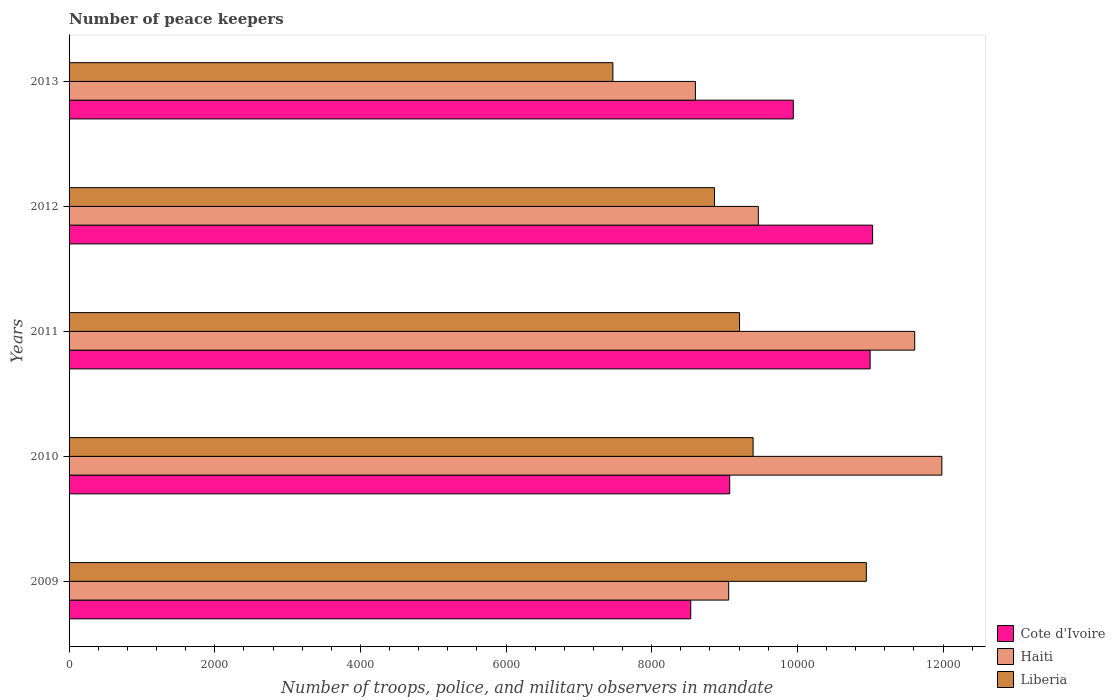How many groups of bars are there?
Your answer should be compact. 5. Are the number of bars per tick equal to the number of legend labels?
Your response must be concise. Yes. How many bars are there on the 3rd tick from the bottom?
Offer a very short reply. 3. What is the label of the 4th group of bars from the top?
Your response must be concise. 2010. In how many cases, is the number of bars for a given year not equal to the number of legend labels?
Your response must be concise. 0. What is the number of peace keepers in in Haiti in 2009?
Ensure brevity in your answer.  9057. Across all years, what is the maximum number of peace keepers in in Liberia?
Your answer should be compact. 1.09e+04. Across all years, what is the minimum number of peace keepers in in Cote d'Ivoire?
Your answer should be compact. 8536. In which year was the number of peace keepers in in Liberia minimum?
Your answer should be compact. 2013. What is the total number of peace keepers in in Liberia in the graph?
Provide a short and direct response. 4.59e+04. What is the difference between the number of peace keepers in in Cote d'Ivoire in 2012 and that in 2013?
Give a very brief answer. 1089. What is the difference between the number of peace keepers in in Haiti in 2010 and the number of peace keepers in in Liberia in 2012?
Make the answer very short. 3122. What is the average number of peace keepers in in Haiti per year?
Your answer should be compact. 1.01e+04. In the year 2009, what is the difference between the number of peace keepers in in Haiti and number of peace keepers in in Liberia?
Offer a very short reply. -1890. In how many years, is the number of peace keepers in in Cote d'Ivoire greater than 2000 ?
Your response must be concise. 5. What is the ratio of the number of peace keepers in in Cote d'Ivoire in 2009 to that in 2010?
Provide a short and direct response. 0.94. What is the difference between the highest and the second highest number of peace keepers in in Liberia?
Your answer should be very brief. 1555. What is the difference between the highest and the lowest number of peace keepers in in Haiti?
Keep it short and to the point. 3384. In how many years, is the number of peace keepers in in Cote d'Ivoire greater than the average number of peace keepers in in Cote d'Ivoire taken over all years?
Provide a short and direct response. 3. What does the 3rd bar from the top in 2012 represents?
Your answer should be compact. Cote d'Ivoire. What does the 1st bar from the bottom in 2009 represents?
Provide a succinct answer. Cote d'Ivoire. Is it the case that in every year, the sum of the number of peace keepers in in Liberia and number of peace keepers in in Cote d'Ivoire is greater than the number of peace keepers in in Haiti?
Your answer should be very brief. Yes. How many bars are there?
Keep it short and to the point. 15. Are all the bars in the graph horizontal?
Your answer should be compact. Yes. What is the difference between two consecutive major ticks on the X-axis?
Make the answer very short. 2000. How many legend labels are there?
Give a very brief answer. 3. How are the legend labels stacked?
Your response must be concise. Vertical. What is the title of the graph?
Keep it short and to the point. Number of peace keepers. What is the label or title of the X-axis?
Offer a terse response. Number of troops, police, and military observers in mandate. What is the Number of troops, police, and military observers in mandate in Cote d'Ivoire in 2009?
Offer a terse response. 8536. What is the Number of troops, police, and military observers in mandate of Haiti in 2009?
Provide a succinct answer. 9057. What is the Number of troops, police, and military observers in mandate of Liberia in 2009?
Ensure brevity in your answer.  1.09e+04. What is the Number of troops, police, and military observers in mandate in Cote d'Ivoire in 2010?
Offer a terse response. 9071. What is the Number of troops, police, and military observers in mandate in Haiti in 2010?
Ensure brevity in your answer.  1.20e+04. What is the Number of troops, police, and military observers in mandate in Liberia in 2010?
Keep it short and to the point. 9392. What is the Number of troops, police, and military observers in mandate of Cote d'Ivoire in 2011?
Make the answer very short. 1.10e+04. What is the Number of troops, police, and military observers in mandate in Haiti in 2011?
Make the answer very short. 1.16e+04. What is the Number of troops, police, and military observers in mandate of Liberia in 2011?
Provide a succinct answer. 9206. What is the Number of troops, police, and military observers in mandate in Cote d'Ivoire in 2012?
Provide a succinct answer. 1.10e+04. What is the Number of troops, police, and military observers in mandate in Haiti in 2012?
Keep it short and to the point. 9464. What is the Number of troops, police, and military observers in mandate of Liberia in 2012?
Offer a very short reply. 8862. What is the Number of troops, police, and military observers in mandate in Cote d'Ivoire in 2013?
Give a very brief answer. 9944. What is the Number of troops, police, and military observers in mandate of Haiti in 2013?
Provide a succinct answer. 8600. What is the Number of troops, police, and military observers in mandate in Liberia in 2013?
Offer a very short reply. 7467. Across all years, what is the maximum Number of troops, police, and military observers in mandate of Cote d'Ivoire?
Provide a short and direct response. 1.10e+04. Across all years, what is the maximum Number of troops, police, and military observers in mandate in Haiti?
Provide a succinct answer. 1.20e+04. Across all years, what is the maximum Number of troops, police, and military observers in mandate in Liberia?
Your answer should be very brief. 1.09e+04. Across all years, what is the minimum Number of troops, police, and military observers in mandate in Cote d'Ivoire?
Your answer should be very brief. 8536. Across all years, what is the minimum Number of troops, police, and military observers in mandate in Haiti?
Your answer should be compact. 8600. Across all years, what is the minimum Number of troops, police, and military observers in mandate in Liberia?
Offer a terse response. 7467. What is the total Number of troops, police, and military observers in mandate of Cote d'Ivoire in the graph?
Make the answer very short. 4.96e+04. What is the total Number of troops, police, and military observers in mandate of Haiti in the graph?
Your answer should be compact. 5.07e+04. What is the total Number of troops, police, and military observers in mandate of Liberia in the graph?
Offer a terse response. 4.59e+04. What is the difference between the Number of troops, police, and military observers in mandate in Cote d'Ivoire in 2009 and that in 2010?
Your answer should be very brief. -535. What is the difference between the Number of troops, police, and military observers in mandate of Haiti in 2009 and that in 2010?
Your response must be concise. -2927. What is the difference between the Number of troops, police, and military observers in mandate in Liberia in 2009 and that in 2010?
Offer a terse response. 1555. What is the difference between the Number of troops, police, and military observers in mandate of Cote d'Ivoire in 2009 and that in 2011?
Keep it short and to the point. -2463. What is the difference between the Number of troops, police, and military observers in mandate in Haiti in 2009 and that in 2011?
Keep it short and to the point. -2554. What is the difference between the Number of troops, police, and military observers in mandate of Liberia in 2009 and that in 2011?
Give a very brief answer. 1741. What is the difference between the Number of troops, police, and military observers in mandate in Cote d'Ivoire in 2009 and that in 2012?
Give a very brief answer. -2497. What is the difference between the Number of troops, police, and military observers in mandate in Haiti in 2009 and that in 2012?
Offer a very short reply. -407. What is the difference between the Number of troops, police, and military observers in mandate in Liberia in 2009 and that in 2012?
Your answer should be compact. 2085. What is the difference between the Number of troops, police, and military observers in mandate of Cote d'Ivoire in 2009 and that in 2013?
Offer a terse response. -1408. What is the difference between the Number of troops, police, and military observers in mandate of Haiti in 2009 and that in 2013?
Your answer should be compact. 457. What is the difference between the Number of troops, police, and military observers in mandate of Liberia in 2009 and that in 2013?
Keep it short and to the point. 3480. What is the difference between the Number of troops, police, and military observers in mandate of Cote d'Ivoire in 2010 and that in 2011?
Keep it short and to the point. -1928. What is the difference between the Number of troops, police, and military observers in mandate of Haiti in 2010 and that in 2011?
Make the answer very short. 373. What is the difference between the Number of troops, police, and military observers in mandate of Liberia in 2010 and that in 2011?
Make the answer very short. 186. What is the difference between the Number of troops, police, and military observers in mandate of Cote d'Ivoire in 2010 and that in 2012?
Keep it short and to the point. -1962. What is the difference between the Number of troops, police, and military observers in mandate in Haiti in 2010 and that in 2012?
Offer a terse response. 2520. What is the difference between the Number of troops, police, and military observers in mandate of Liberia in 2010 and that in 2012?
Your answer should be very brief. 530. What is the difference between the Number of troops, police, and military observers in mandate of Cote d'Ivoire in 2010 and that in 2013?
Your response must be concise. -873. What is the difference between the Number of troops, police, and military observers in mandate in Haiti in 2010 and that in 2013?
Keep it short and to the point. 3384. What is the difference between the Number of troops, police, and military observers in mandate in Liberia in 2010 and that in 2013?
Offer a very short reply. 1925. What is the difference between the Number of troops, police, and military observers in mandate in Cote d'Ivoire in 2011 and that in 2012?
Make the answer very short. -34. What is the difference between the Number of troops, police, and military observers in mandate of Haiti in 2011 and that in 2012?
Your answer should be compact. 2147. What is the difference between the Number of troops, police, and military observers in mandate of Liberia in 2011 and that in 2012?
Provide a succinct answer. 344. What is the difference between the Number of troops, police, and military observers in mandate of Cote d'Ivoire in 2011 and that in 2013?
Your response must be concise. 1055. What is the difference between the Number of troops, police, and military observers in mandate in Haiti in 2011 and that in 2013?
Offer a very short reply. 3011. What is the difference between the Number of troops, police, and military observers in mandate in Liberia in 2011 and that in 2013?
Your answer should be compact. 1739. What is the difference between the Number of troops, police, and military observers in mandate in Cote d'Ivoire in 2012 and that in 2013?
Offer a terse response. 1089. What is the difference between the Number of troops, police, and military observers in mandate in Haiti in 2012 and that in 2013?
Give a very brief answer. 864. What is the difference between the Number of troops, police, and military observers in mandate of Liberia in 2012 and that in 2013?
Your response must be concise. 1395. What is the difference between the Number of troops, police, and military observers in mandate in Cote d'Ivoire in 2009 and the Number of troops, police, and military observers in mandate in Haiti in 2010?
Make the answer very short. -3448. What is the difference between the Number of troops, police, and military observers in mandate in Cote d'Ivoire in 2009 and the Number of troops, police, and military observers in mandate in Liberia in 2010?
Your answer should be compact. -856. What is the difference between the Number of troops, police, and military observers in mandate of Haiti in 2009 and the Number of troops, police, and military observers in mandate of Liberia in 2010?
Offer a terse response. -335. What is the difference between the Number of troops, police, and military observers in mandate of Cote d'Ivoire in 2009 and the Number of troops, police, and military observers in mandate of Haiti in 2011?
Offer a very short reply. -3075. What is the difference between the Number of troops, police, and military observers in mandate of Cote d'Ivoire in 2009 and the Number of troops, police, and military observers in mandate of Liberia in 2011?
Ensure brevity in your answer.  -670. What is the difference between the Number of troops, police, and military observers in mandate of Haiti in 2009 and the Number of troops, police, and military observers in mandate of Liberia in 2011?
Provide a short and direct response. -149. What is the difference between the Number of troops, police, and military observers in mandate of Cote d'Ivoire in 2009 and the Number of troops, police, and military observers in mandate of Haiti in 2012?
Give a very brief answer. -928. What is the difference between the Number of troops, police, and military observers in mandate of Cote d'Ivoire in 2009 and the Number of troops, police, and military observers in mandate of Liberia in 2012?
Your answer should be compact. -326. What is the difference between the Number of troops, police, and military observers in mandate in Haiti in 2009 and the Number of troops, police, and military observers in mandate in Liberia in 2012?
Your answer should be compact. 195. What is the difference between the Number of troops, police, and military observers in mandate of Cote d'Ivoire in 2009 and the Number of troops, police, and military observers in mandate of Haiti in 2013?
Offer a terse response. -64. What is the difference between the Number of troops, police, and military observers in mandate of Cote d'Ivoire in 2009 and the Number of troops, police, and military observers in mandate of Liberia in 2013?
Offer a terse response. 1069. What is the difference between the Number of troops, police, and military observers in mandate in Haiti in 2009 and the Number of troops, police, and military observers in mandate in Liberia in 2013?
Your response must be concise. 1590. What is the difference between the Number of troops, police, and military observers in mandate of Cote d'Ivoire in 2010 and the Number of troops, police, and military observers in mandate of Haiti in 2011?
Offer a very short reply. -2540. What is the difference between the Number of troops, police, and military observers in mandate of Cote d'Ivoire in 2010 and the Number of troops, police, and military observers in mandate of Liberia in 2011?
Provide a short and direct response. -135. What is the difference between the Number of troops, police, and military observers in mandate in Haiti in 2010 and the Number of troops, police, and military observers in mandate in Liberia in 2011?
Offer a very short reply. 2778. What is the difference between the Number of troops, police, and military observers in mandate in Cote d'Ivoire in 2010 and the Number of troops, police, and military observers in mandate in Haiti in 2012?
Provide a short and direct response. -393. What is the difference between the Number of troops, police, and military observers in mandate in Cote d'Ivoire in 2010 and the Number of troops, police, and military observers in mandate in Liberia in 2012?
Ensure brevity in your answer.  209. What is the difference between the Number of troops, police, and military observers in mandate of Haiti in 2010 and the Number of troops, police, and military observers in mandate of Liberia in 2012?
Your answer should be very brief. 3122. What is the difference between the Number of troops, police, and military observers in mandate of Cote d'Ivoire in 2010 and the Number of troops, police, and military observers in mandate of Haiti in 2013?
Ensure brevity in your answer.  471. What is the difference between the Number of troops, police, and military observers in mandate in Cote d'Ivoire in 2010 and the Number of troops, police, and military observers in mandate in Liberia in 2013?
Keep it short and to the point. 1604. What is the difference between the Number of troops, police, and military observers in mandate of Haiti in 2010 and the Number of troops, police, and military observers in mandate of Liberia in 2013?
Your response must be concise. 4517. What is the difference between the Number of troops, police, and military observers in mandate in Cote d'Ivoire in 2011 and the Number of troops, police, and military observers in mandate in Haiti in 2012?
Offer a terse response. 1535. What is the difference between the Number of troops, police, and military observers in mandate in Cote d'Ivoire in 2011 and the Number of troops, police, and military observers in mandate in Liberia in 2012?
Offer a terse response. 2137. What is the difference between the Number of troops, police, and military observers in mandate in Haiti in 2011 and the Number of troops, police, and military observers in mandate in Liberia in 2012?
Give a very brief answer. 2749. What is the difference between the Number of troops, police, and military observers in mandate of Cote d'Ivoire in 2011 and the Number of troops, police, and military observers in mandate of Haiti in 2013?
Provide a succinct answer. 2399. What is the difference between the Number of troops, police, and military observers in mandate of Cote d'Ivoire in 2011 and the Number of troops, police, and military observers in mandate of Liberia in 2013?
Offer a very short reply. 3532. What is the difference between the Number of troops, police, and military observers in mandate of Haiti in 2011 and the Number of troops, police, and military observers in mandate of Liberia in 2013?
Your answer should be very brief. 4144. What is the difference between the Number of troops, police, and military observers in mandate of Cote d'Ivoire in 2012 and the Number of troops, police, and military observers in mandate of Haiti in 2013?
Offer a terse response. 2433. What is the difference between the Number of troops, police, and military observers in mandate of Cote d'Ivoire in 2012 and the Number of troops, police, and military observers in mandate of Liberia in 2013?
Offer a terse response. 3566. What is the difference between the Number of troops, police, and military observers in mandate in Haiti in 2012 and the Number of troops, police, and military observers in mandate in Liberia in 2013?
Offer a terse response. 1997. What is the average Number of troops, police, and military observers in mandate in Cote d'Ivoire per year?
Make the answer very short. 9916.6. What is the average Number of troops, police, and military observers in mandate in Haiti per year?
Offer a terse response. 1.01e+04. What is the average Number of troops, police, and military observers in mandate of Liberia per year?
Your answer should be compact. 9174.8. In the year 2009, what is the difference between the Number of troops, police, and military observers in mandate in Cote d'Ivoire and Number of troops, police, and military observers in mandate in Haiti?
Provide a short and direct response. -521. In the year 2009, what is the difference between the Number of troops, police, and military observers in mandate of Cote d'Ivoire and Number of troops, police, and military observers in mandate of Liberia?
Your answer should be compact. -2411. In the year 2009, what is the difference between the Number of troops, police, and military observers in mandate of Haiti and Number of troops, police, and military observers in mandate of Liberia?
Keep it short and to the point. -1890. In the year 2010, what is the difference between the Number of troops, police, and military observers in mandate of Cote d'Ivoire and Number of troops, police, and military observers in mandate of Haiti?
Provide a short and direct response. -2913. In the year 2010, what is the difference between the Number of troops, police, and military observers in mandate in Cote d'Ivoire and Number of troops, police, and military observers in mandate in Liberia?
Give a very brief answer. -321. In the year 2010, what is the difference between the Number of troops, police, and military observers in mandate in Haiti and Number of troops, police, and military observers in mandate in Liberia?
Your answer should be compact. 2592. In the year 2011, what is the difference between the Number of troops, police, and military observers in mandate in Cote d'Ivoire and Number of troops, police, and military observers in mandate in Haiti?
Keep it short and to the point. -612. In the year 2011, what is the difference between the Number of troops, police, and military observers in mandate in Cote d'Ivoire and Number of troops, police, and military observers in mandate in Liberia?
Ensure brevity in your answer.  1793. In the year 2011, what is the difference between the Number of troops, police, and military observers in mandate of Haiti and Number of troops, police, and military observers in mandate of Liberia?
Your answer should be compact. 2405. In the year 2012, what is the difference between the Number of troops, police, and military observers in mandate of Cote d'Ivoire and Number of troops, police, and military observers in mandate of Haiti?
Offer a terse response. 1569. In the year 2012, what is the difference between the Number of troops, police, and military observers in mandate of Cote d'Ivoire and Number of troops, police, and military observers in mandate of Liberia?
Make the answer very short. 2171. In the year 2012, what is the difference between the Number of troops, police, and military observers in mandate of Haiti and Number of troops, police, and military observers in mandate of Liberia?
Your response must be concise. 602. In the year 2013, what is the difference between the Number of troops, police, and military observers in mandate in Cote d'Ivoire and Number of troops, police, and military observers in mandate in Haiti?
Ensure brevity in your answer.  1344. In the year 2013, what is the difference between the Number of troops, police, and military observers in mandate of Cote d'Ivoire and Number of troops, police, and military observers in mandate of Liberia?
Keep it short and to the point. 2477. In the year 2013, what is the difference between the Number of troops, police, and military observers in mandate of Haiti and Number of troops, police, and military observers in mandate of Liberia?
Keep it short and to the point. 1133. What is the ratio of the Number of troops, police, and military observers in mandate of Cote d'Ivoire in 2009 to that in 2010?
Give a very brief answer. 0.94. What is the ratio of the Number of troops, police, and military observers in mandate in Haiti in 2009 to that in 2010?
Your answer should be compact. 0.76. What is the ratio of the Number of troops, police, and military observers in mandate of Liberia in 2009 to that in 2010?
Give a very brief answer. 1.17. What is the ratio of the Number of troops, police, and military observers in mandate in Cote d'Ivoire in 2009 to that in 2011?
Offer a very short reply. 0.78. What is the ratio of the Number of troops, police, and military observers in mandate in Haiti in 2009 to that in 2011?
Give a very brief answer. 0.78. What is the ratio of the Number of troops, police, and military observers in mandate of Liberia in 2009 to that in 2011?
Your answer should be compact. 1.19. What is the ratio of the Number of troops, police, and military observers in mandate in Cote d'Ivoire in 2009 to that in 2012?
Provide a short and direct response. 0.77. What is the ratio of the Number of troops, police, and military observers in mandate in Liberia in 2009 to that in 2012?
Provide a succinct answer. 1.24. What is the ratio of the Number of troops, police, and military observers in mandate of Cote d'Ivoire in 2009 to that in 2013?
Your answer should be very brief. 0.86. What is the ratio of the Number of troops, police, and military observers in mandate in Haiti in 2009 to that in 2013?
Give a very brief answer. 1.05. What is the ratio of the Number of troops, police, and military observers in mandate of Liberia in 2009 to that in 2013?
Your response must be concise. 1.47. What is the ratio of the Number of troops, police, and military observers in mandate in Cote d'Ivoire in 2010 to that in 2011?
Provide a succinct answer. 0.82. What is the ratio of the Number of troops, police, and military observers in mandate of Haiti in 2010 to that in 2011?
Your response must be concise. 1.03. What is the ratio of the Number of troops, police, and military observers in mandate in Liberia in 2010 to that in 2011?
Give a very brief answer. 1.02. What is the ratio of the Number of troops, police, and military observers in mandate in Cote d'Ivoire in 2010 to that in 2012?
Offer a terse response. 0.82. What is the ratio of the Number of troops, police, and military observers in mandate of Haiti in 2010 to that in 2012?
Offer a terse response. 1.27. What is the ratio of the Number of troops, police, and military observers in mandate of Liberia in 2010 to that in 2012?
Your answer should be compact. 1.06. What is the ratio of the Number of troops, police, and military observers in mandate in Cote d'Ivoire in 2010 to that in 2013?
Offer a very short reply. 0.91. What is the ratio of the Number of troops, police, and military observers in mandate in Haiti in 2010 to that in 2013?
Ensure brevity in your answer.  1.39. What is the ratio of the Number of troops, police, and military observers in mandate of Liberia in 2010 to that in 2013?
Your response must be concise. 1.26. What is the ratio of the Number of troops, police, and military observers in mandate of Haiti in 2011 to that in 2012?
Make the answer very short. 1.23. What is the ratio of the Number of troops, police, and military observers in mandate of Liberia in 2011 to that in 2012?
Your answer should be very brief. 1.04. What is the ratio of the Number of troops, police, and military observers in mandate in Cote d'Ivoire in 2011 to that in 2013?
Keep it short and to the point. 1.11. What is the ratio of the Number of troops, police, and military observers in mandate of Haiti in 2011 to that in 2013?
Give a very brief answer. 1.35. What is the ratio of the Number of troops, police, and military observers in mandate of Liberia in 2011 to that in 2013?
Provide a short and direct response. 1.23. What is the ratio of the Number of troops, police, and military observers in mandate of Cote d'Ivoire in 2012 to that in 2013?
Make the answer very short. 1.11. What is the ratio of the Number of troops, police, and military observers in mandate of Haiti in 2012 to that in 2013?
Provide a short and direct response. 1.1. What is the ratio of the Number of troops, police, and military observers in mandate in Liberia in 2012 to that in 2013?
Your answer should be very brief. 1.19. What is the difference between the highest and the second highest Number of troops, police, and military observers in mandate in Cote d'Ivoire?
Ensure brevity in your answer.  34. What is the difference between the highest and the second highest Number of troops, police, and military observers in mandate of Haiti?
Your response must be concise. 373. What is the difference between the highest and the second highest Number of troops, police, and military observers in mandate of Liberia?
Give a very brief answer. 1555. What is the difference between the highest and the lowest Number of troops, police, and military observers in mandate of Cote d'Ivoire?
Make the answer very short. 2497. What is the difference between the highest and the lowest Number of troops, police, and military observers in mandate in Haiti?
Give a very brief answer. 3384. What is the difference between the highest and the lowest Number of troops, police, and military observers in mandate in Liberia?
Your response must be concise. 3480. 